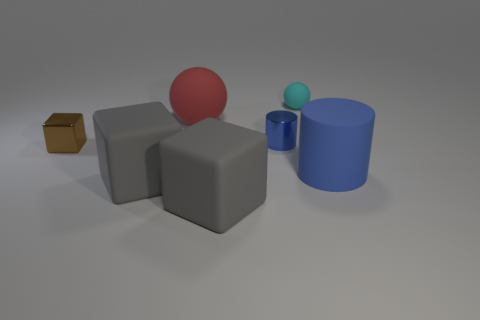There is a metallic object that is the same color as the large cylinder; what is its shape?
Your answer should be compact. Cylinder. Are there any large rubber cylinders that have the same color as the tiny metallic cylinder?
Ensure brevity in your answer.  Yes. There is a blue metallic thing; is its size the same as the metallic object to the left of the blue metal object?
Keep it short and to the point. Yes. There is a block that is behind the blue cylinder in front of the tiny brown thing; what is its color?
Keep it short and to the point. Brown. Does the blue metallic cylinder have the same size as the brown metal thing?
Keep it short and to the point. Yes. There is a rubber object that is both in front of the tiny rubber sphere and behind the small metallic block; what color is it?
Ensure brevity in your answer.  Red. The cyan matte sphere is what size?
Your answer should be compact. Small. Is the color of the rubber object that is on the right side of the cyan ball the same as the small cylinder?
Ensure brevity in your answer.  Yes. Is the number of matte things that are in front of the small cyan sphere greater than the number of shiny things that are behind the small cylinder?
Offer a terse response. Yes. Are there more brown metal things than gray matte cubes?
Make the answer very short. No. 